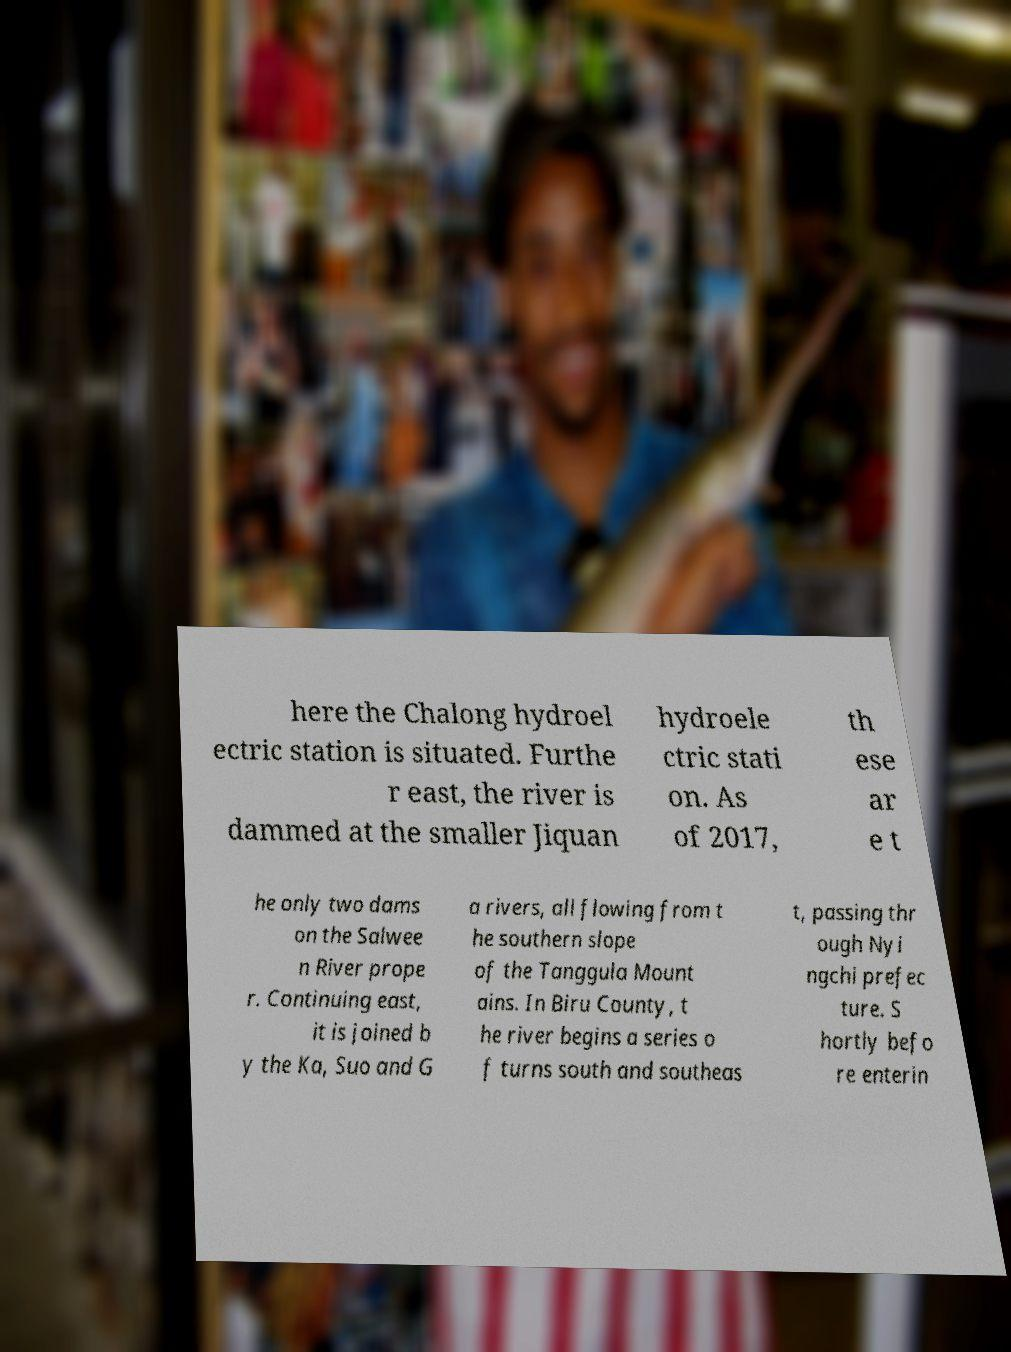There's text embedded in this image that I need extracted. Can you transcribe it verbatim? here the Chalong hydroel ectric station is situated. Furthe r east, the river is dammed at the smaller Jiquan hydroele ctric stati on. As of 2017, th ese ar e t he only two dams on the Salwee n River prope r. Continuing east, it is joined b y the Ka, Suo and G a rivers, all flowing from t he southern slope of the Tanggula Mount ains. In Biru County, t he river begins a series o f turns south and southeas t, passing thr ough Nyi ngchi prefec ture. S hortly befo re enterin 